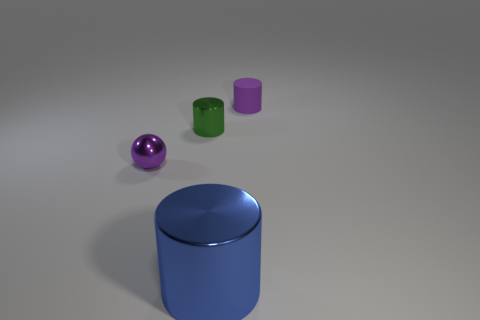Subtract 1 cylinders. How many cylinders are left? 2 Add 4 shiny spheres. How many objects exist? 8 Add 4 small green shiny cylinders. How many small green shiny cylinders are left? 5 Add 3 matte cylinders. How many matte cylinders exist? 4 Subtract 1 purple cylinders. How many objects are left? 3 Subtract all cylinders. How many objects are left? 1 Subtract all purple shiny cubes. Subtract all matte objects. How many objects are left? 3 